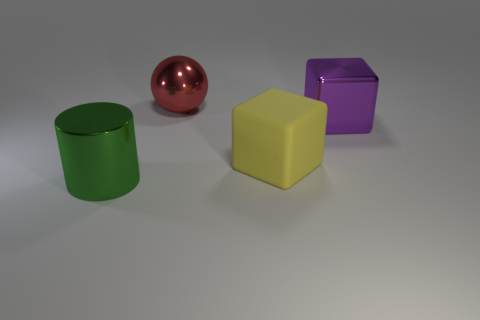Is there anything else that is the same material as the yellow thing?
Your answer should be compact. No. Is there anything else that has the same shape as the big green metallic object?
Provide a short and direct response. No. What is the shape of the purple object that is the same size as the yellow block?
Ensure brevity in your answer.  Cube. How many objects are objects that are to the left of the large red ball or purple matte objects?
Your response must be concise. 1. How many other things are there of the same material as the purple thing?
Your answer should be very brief. 2. There is a metal thing that is to the right of the red ball; how big is it?
Keep it short and to the point. Large. The big red thing that is made of the same material as the green thing is what shape?
Provide a short and direct response. Sphere. Is the large yellow object made of the same material as the big thing on the right side of the yellow rubber block?
Your answer should be compact. No. Is the shape of the metallic thing on the left side of the red ball the same as  the large purple thing?
Your answer should be very brief. No. What material is the purple thing that is the same shape as the yellow matte object?
Make the answer very short. Metal. 